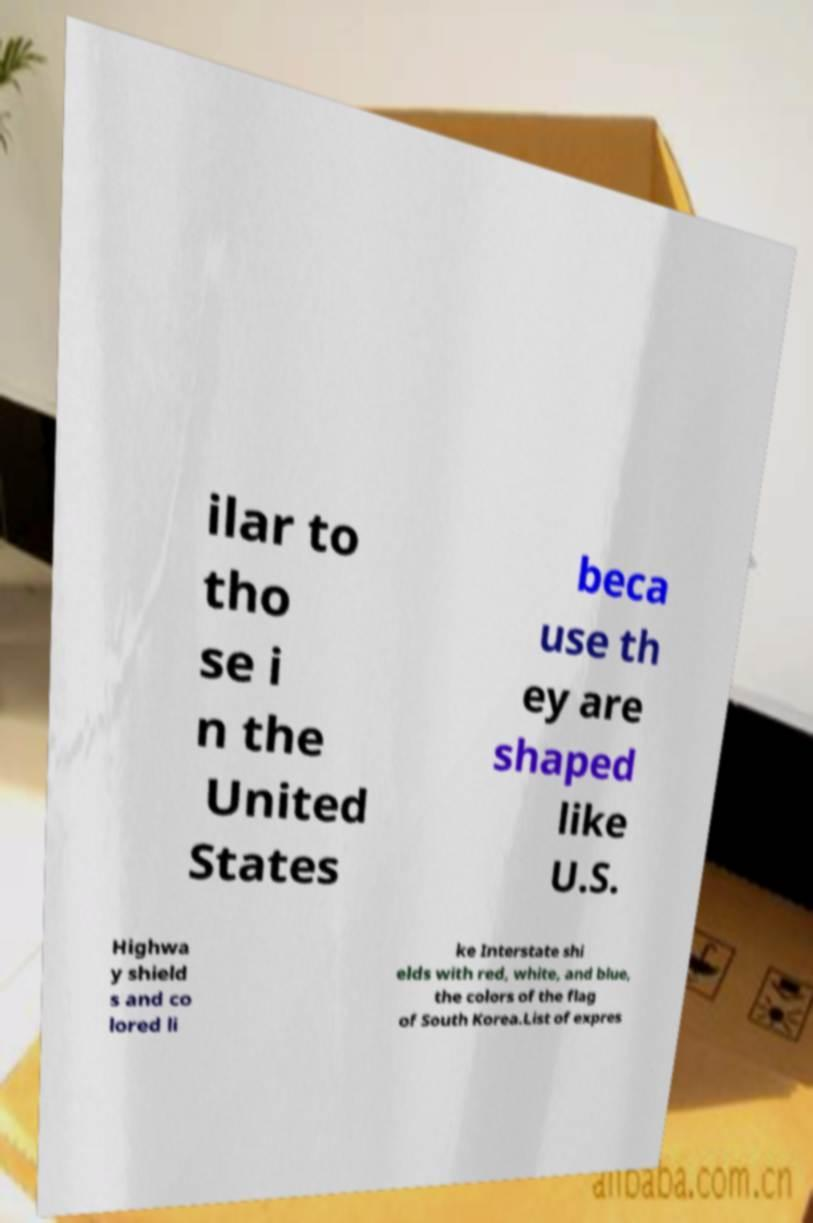Can you read and provide the text displayed in the image?This photo seems to have some interesting text. Can you extract and type it out for me? ilar to tho se i n the United States beca use th ey are shaped like U.S. Highwa y shield s and co lored li ke Interstate shi elds with red, white, and blue, the colors of the flag of South Korea.List of expres 